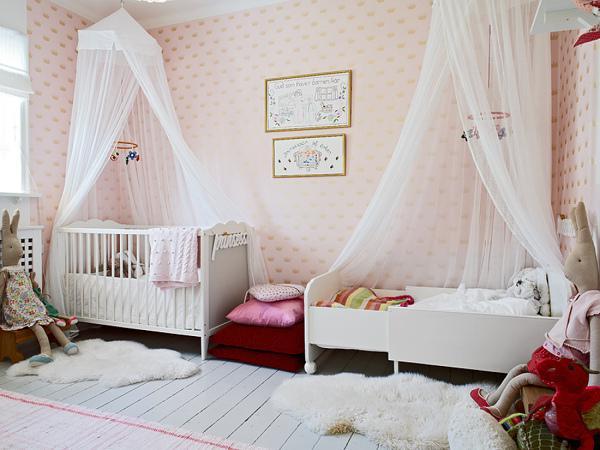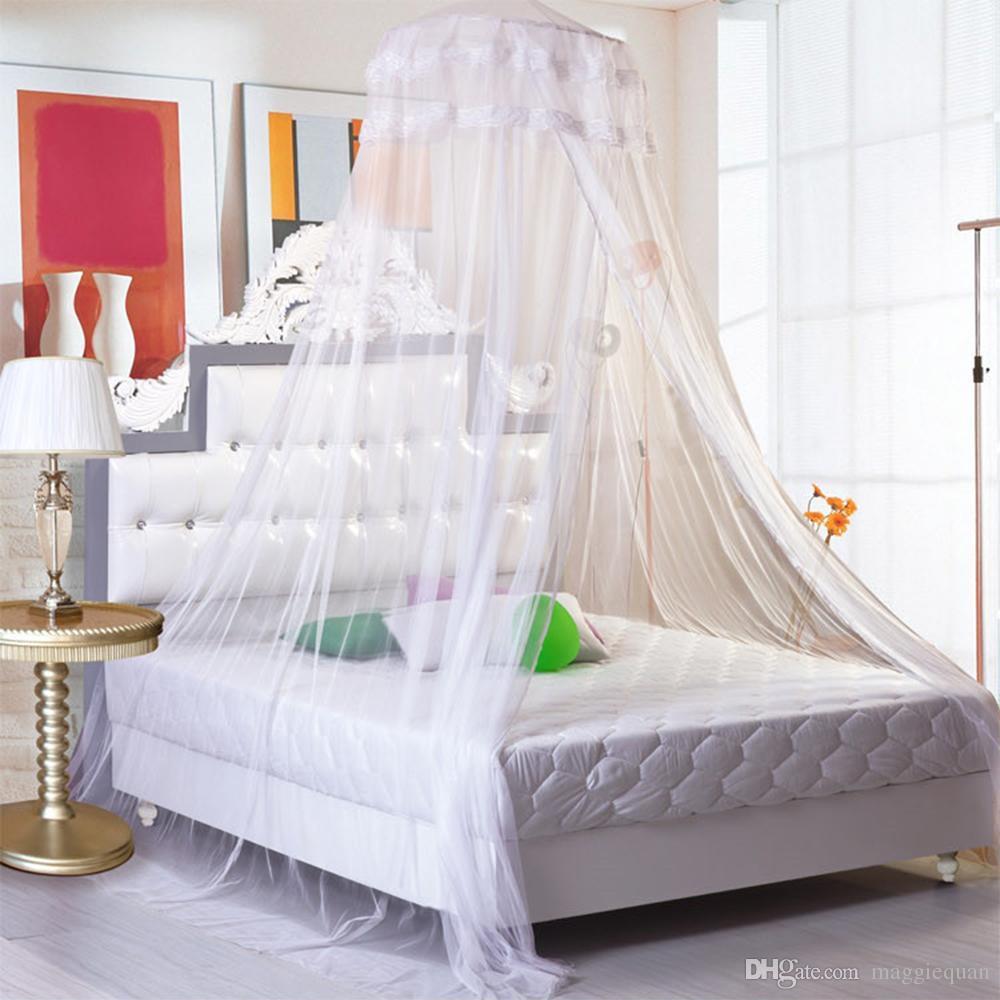The first image is the image on the left, the second image is the image on the right. Evaluate the accuracy of this statement regarding the images: "In one image, gauzy bed curtains are draped from a square frame, and knotted halfway down at each corner.". Is it true? Answer yes or no. No. 